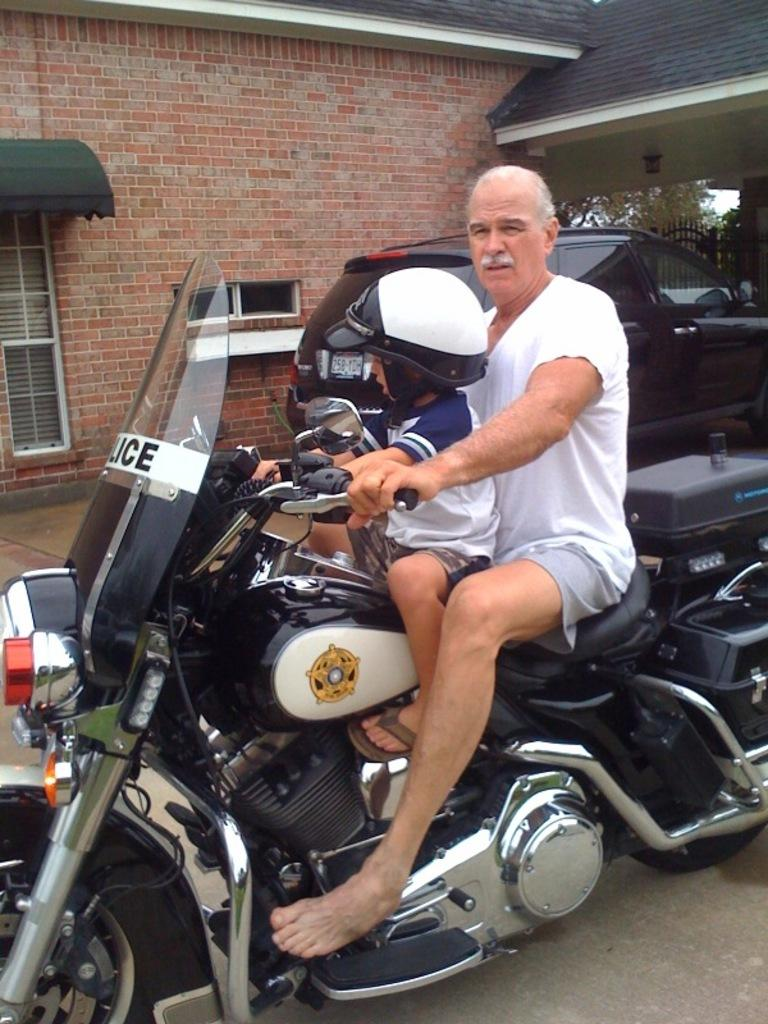Who is present in the image? There is an old man and a boy in the image. What are they doing in the image? The boy is riding a bike, and the old man is also riding the bike. What safety precaution is the boy taking while riding the bike? The boy is wearing a helmet. What can be seen in the background of the image? There is a brick wall and a car in the background of the image. What language is the old man speaking to the boy in the image? There is no indication of any spoken language in the image, so it cannot be determined. --- Facts: 1. There is a dog in the image. 2. The dog is sitting on a chair. 3. The chair is made of wood. 4. There is a table next to the chair. 5. The table has a book on it. Absurd Topics: ocean, dance, fire Conversation: What animal is present in the image? There is a dog in the image. What is the dog doing in the image? The dog is sitting on a chair. What is the chair made of? The chair is made of wood. What is located next to the chair? There is a table next to the chair. What can be seen on the table? The table has a book on it. Reasoning: Let's think step by step in order to produce the conversation. We start by identifying the main subject in the image, which is the dog. Then, we describe the dog's action and the material of the chair. Next, we mention the table and the object on it, which is a book. Each question is designed to elicit a specific detail about the image that is known from the provided facts. Absurd Question/Answer: Can you see the dog dancing in the image? There is no indication of the dog dancing in the image; it is sitting on a chair. --- Facts: 1. There is a group of people in the image. 2. The people are holding hands. 3. They are standing in a circle. 4. There is a fire in the center of the circle. 5. The people are wearing hats. Absurd Topics: snow, piano, bicycle Conversation: How many people are in the image? There is a group of people in the image. What are the people doing in the image? The people are holding hands and standing in a circle. What is located in the center of the circle? There is a fire in the center of the circle. What are the people wearing on their heads? The people are wearing hats. Reasoning: Let's think step by step in order to produce the conversation. We start by identifying the main subjects in the image, 